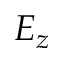Convert formula to latex. <formula><loc_0><loc_0><loc_500><loc_500>E _ { z }</formula> 